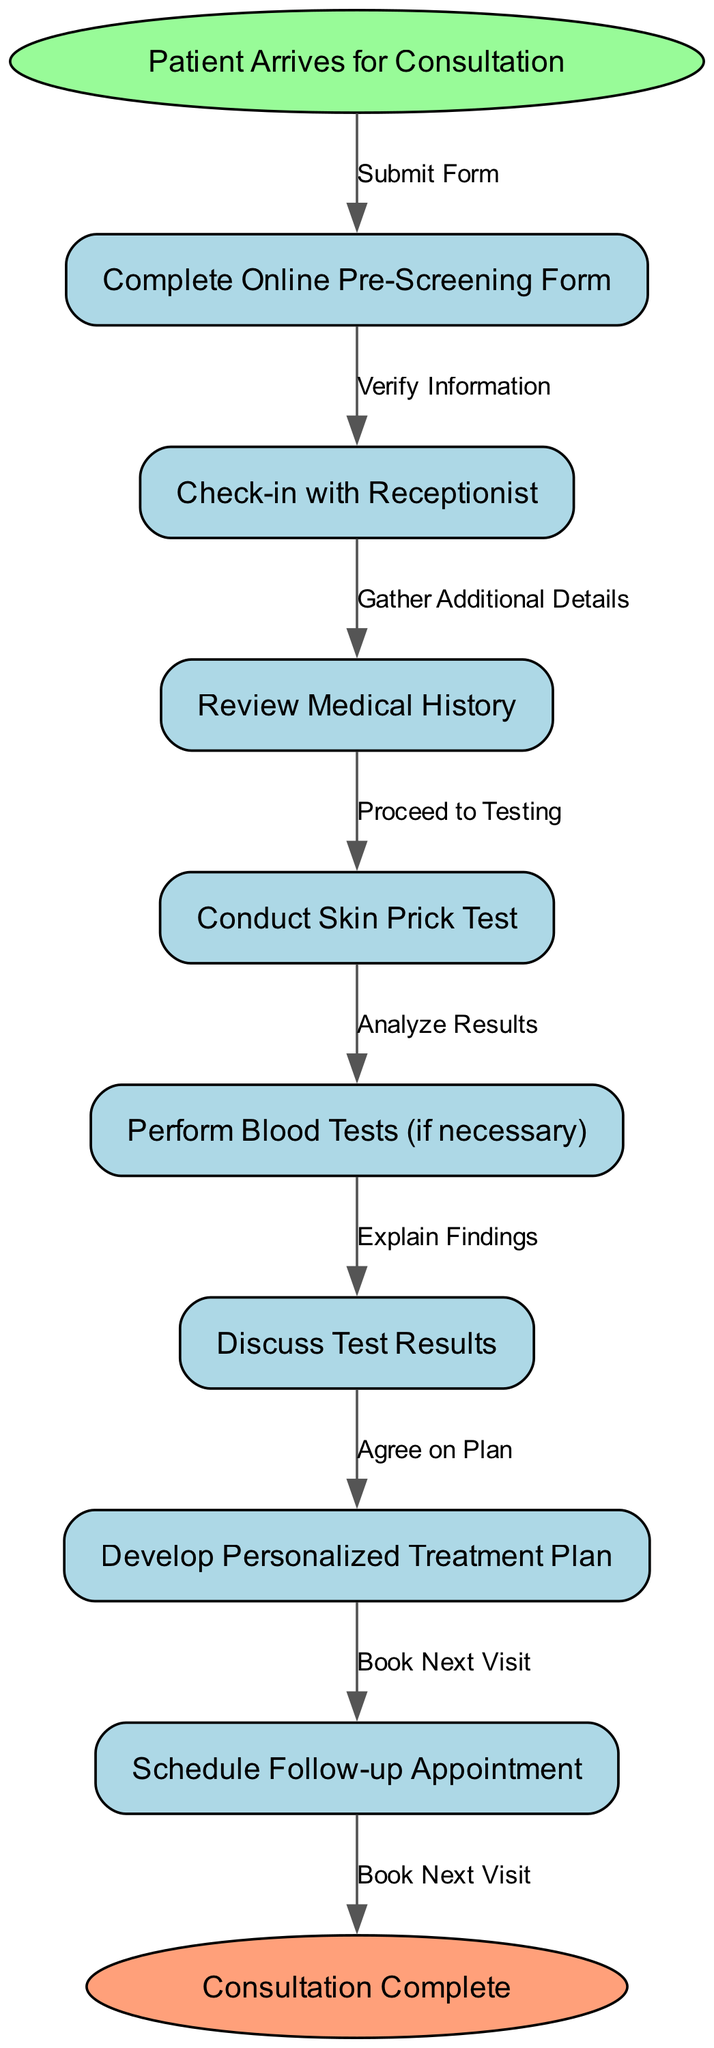What is the starting point of the consultation process? The starting point is indicated at the top of the flow chart and is labeled "Patient Arrives for Consultation".
Answer: Patient Arrives for Consultation How many steps are involved in the intake process? The flow chart shows a total of 8 nodes representing steps, starting from the patient arrival to the completion of the consultation.
Answer: 8 What node comes after "Complete Online Pre-Screening Form"? By following the arrows in the diagram after "Complete Online Pre-Screening Form", it leads to the next step, which is "Check-in with Receptionist".
Answer: Check-in with Receptionist What is the final step of the consultation process? The last node in the chart, connected by an edge from the previous node, is "Consultation Complete".
Answer: Consultation Complete What test is conducted before discussing test results? The flow of the diagram shows that "Conduct Skin Prick Test" is the step performed before "Discuss Test Results".
Answer: Conduct Skin Prick Test Which step involves scheduling a future appointment? In the flow chart, the step that mentions scheduling is "Schedule Follow-up Appointment", which is the last action before completing the consultation.
Answer: Schedule Follow-up Appointment How many edges connect the nodes in the diagram? There are 8 nodes, and for a flow chart of this type, each node connects to the subsequent node with edges; thus, there are 7 edges plus one from the start node, making it a total of 8 edges.
Answer: 8 What leads to the "Develop Personalized Treatment Plan"? The flow chart shows that after discussing test results, the next step is to "Develop Personalized Treatment Plan", which follows the edge coming from "Discuss Test Results".
Answer: Discuss Test Results 